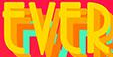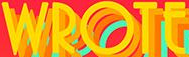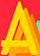What text is displayed in these images sequentially, separated by a semicolon? EVER; WROTE; A 